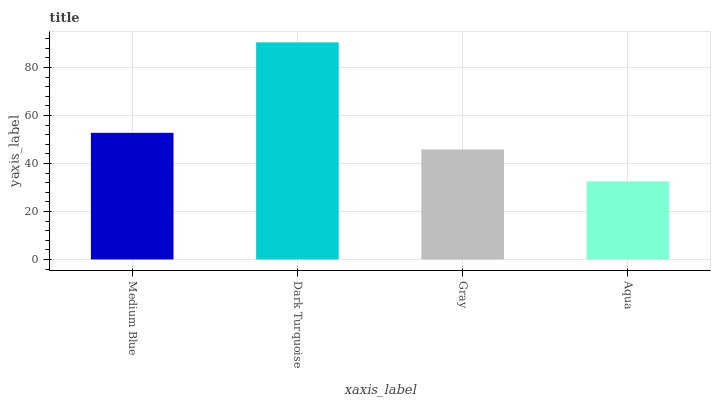Is Aqua the minimum?
Answer yes or no. Yes. Is Dark Turquoise the maximum?
Answer yes or no. Yes. Is Gray the minimum?
Answer yes or no. No. Is Gray the maximum?
Answer yes or no. No. Is Dark Turquoise greater than Gray?
Answer yes or no. Yes. Is Gray less than Dark Turquoise?
Answer yes or no. Yes. Is Gray greater than Dark Turquoise?
Answer yes or no. No. Is Dark Turquoise less than Gray?
Answer yes or no. No. Is Medium Blue the high median?
Answer yes or no. Yes. Is Gray the low median?
Answer yes or no. Yes. Is Gray the high median?
Answer yes or no. No. Is Medium Blue the low median?
Answer yes or no. No. 